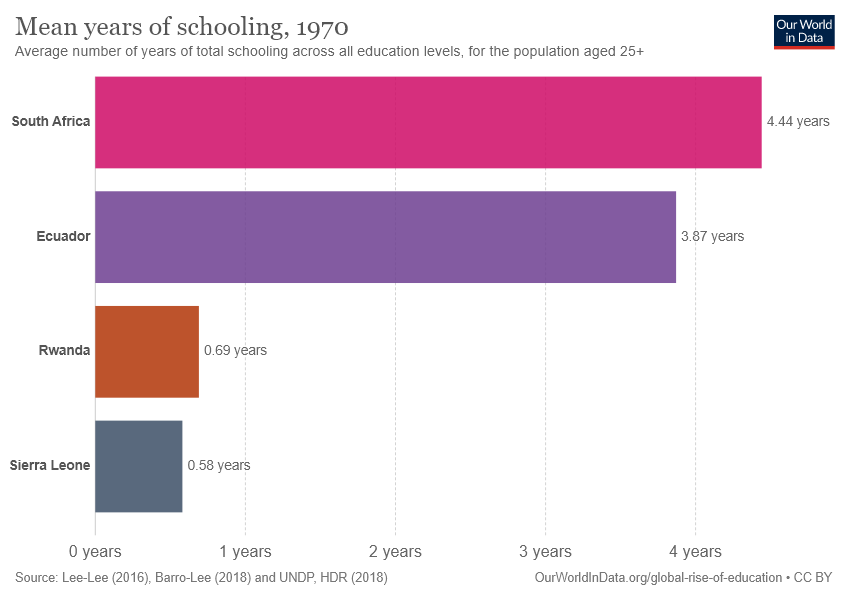Give some essential details in this illustration. The average value of the two smallest bars is greater than 0.60 years, indicating that the two smallest bars have a longer average value than the other bars. In South Africa, the mean years of schooling is 4.44 years. 